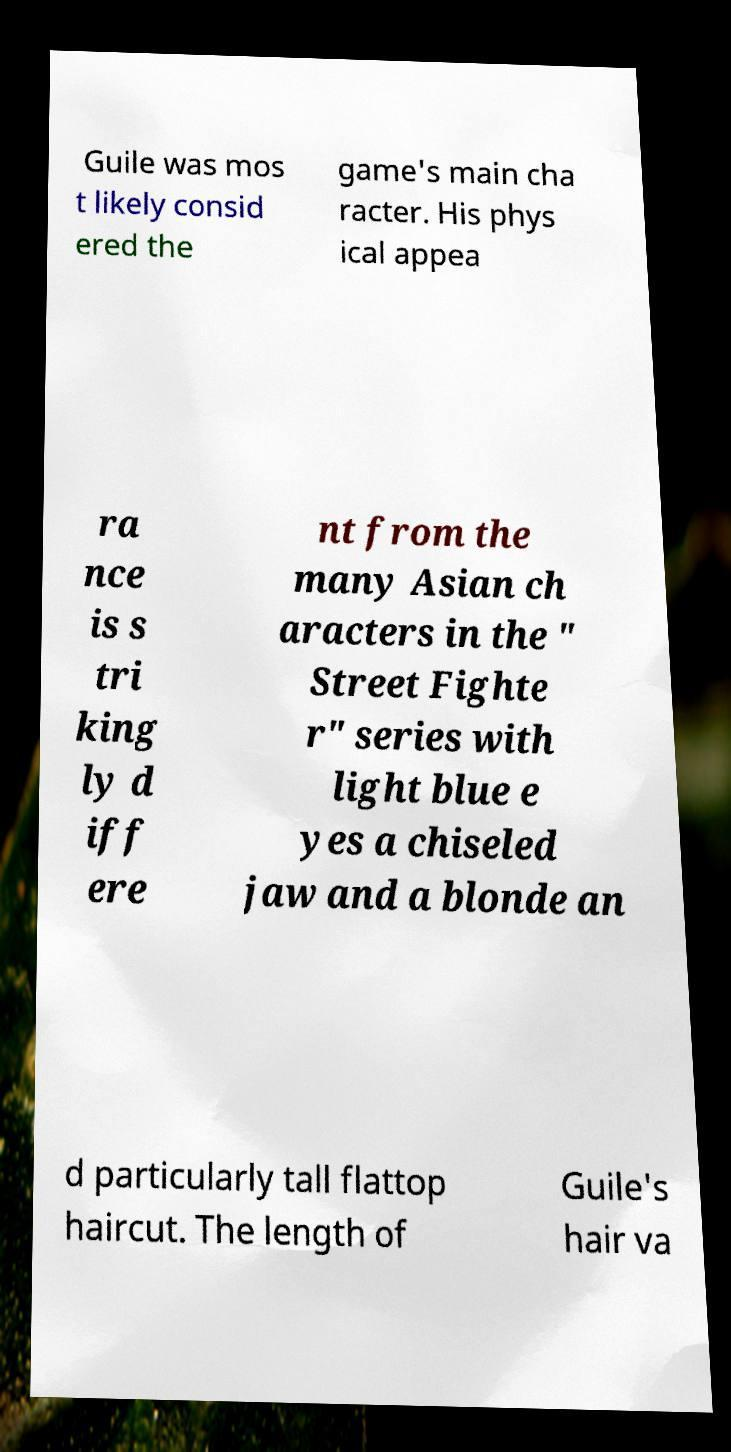What messages or text are displayed in this image? I need them in a readable, typed format. Guile was mos t likely consid ered the game's main cha racter. His phys ical appea ra nce is s tri king ly d iff ere nt from the many Asian ch aracters in the " Street Fighte r" series with light blue e yes a chiseled jaw and a blonde an d particularly tall flattop haircut. The length of Guile's hair va 